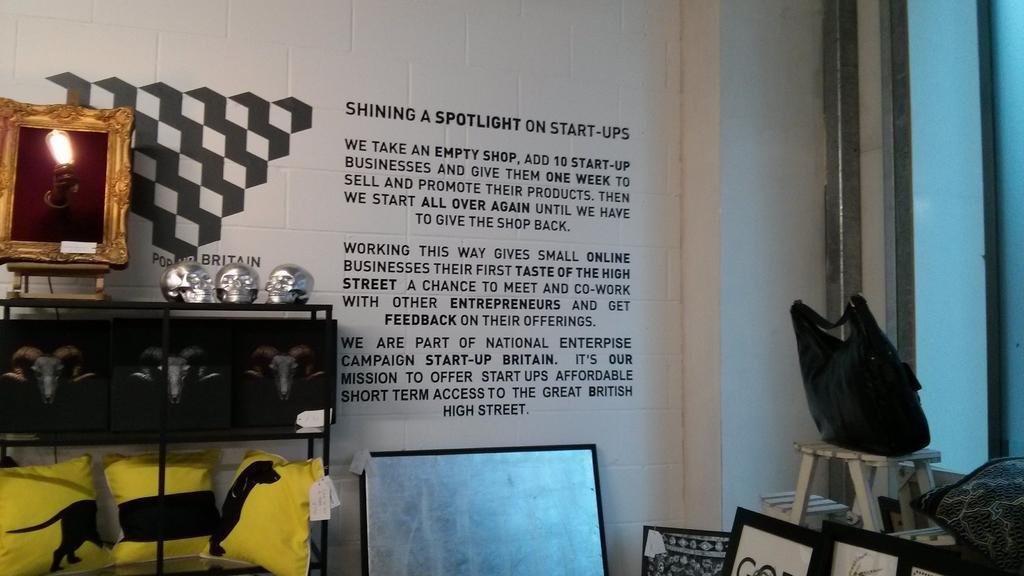Could you give a brief overview of what you see in this image? On the right side of the image we can see frames, pillows and bag on a chair. We can see board and pillows. We can see skulls and frame on the platform and we can see text on the wall. 